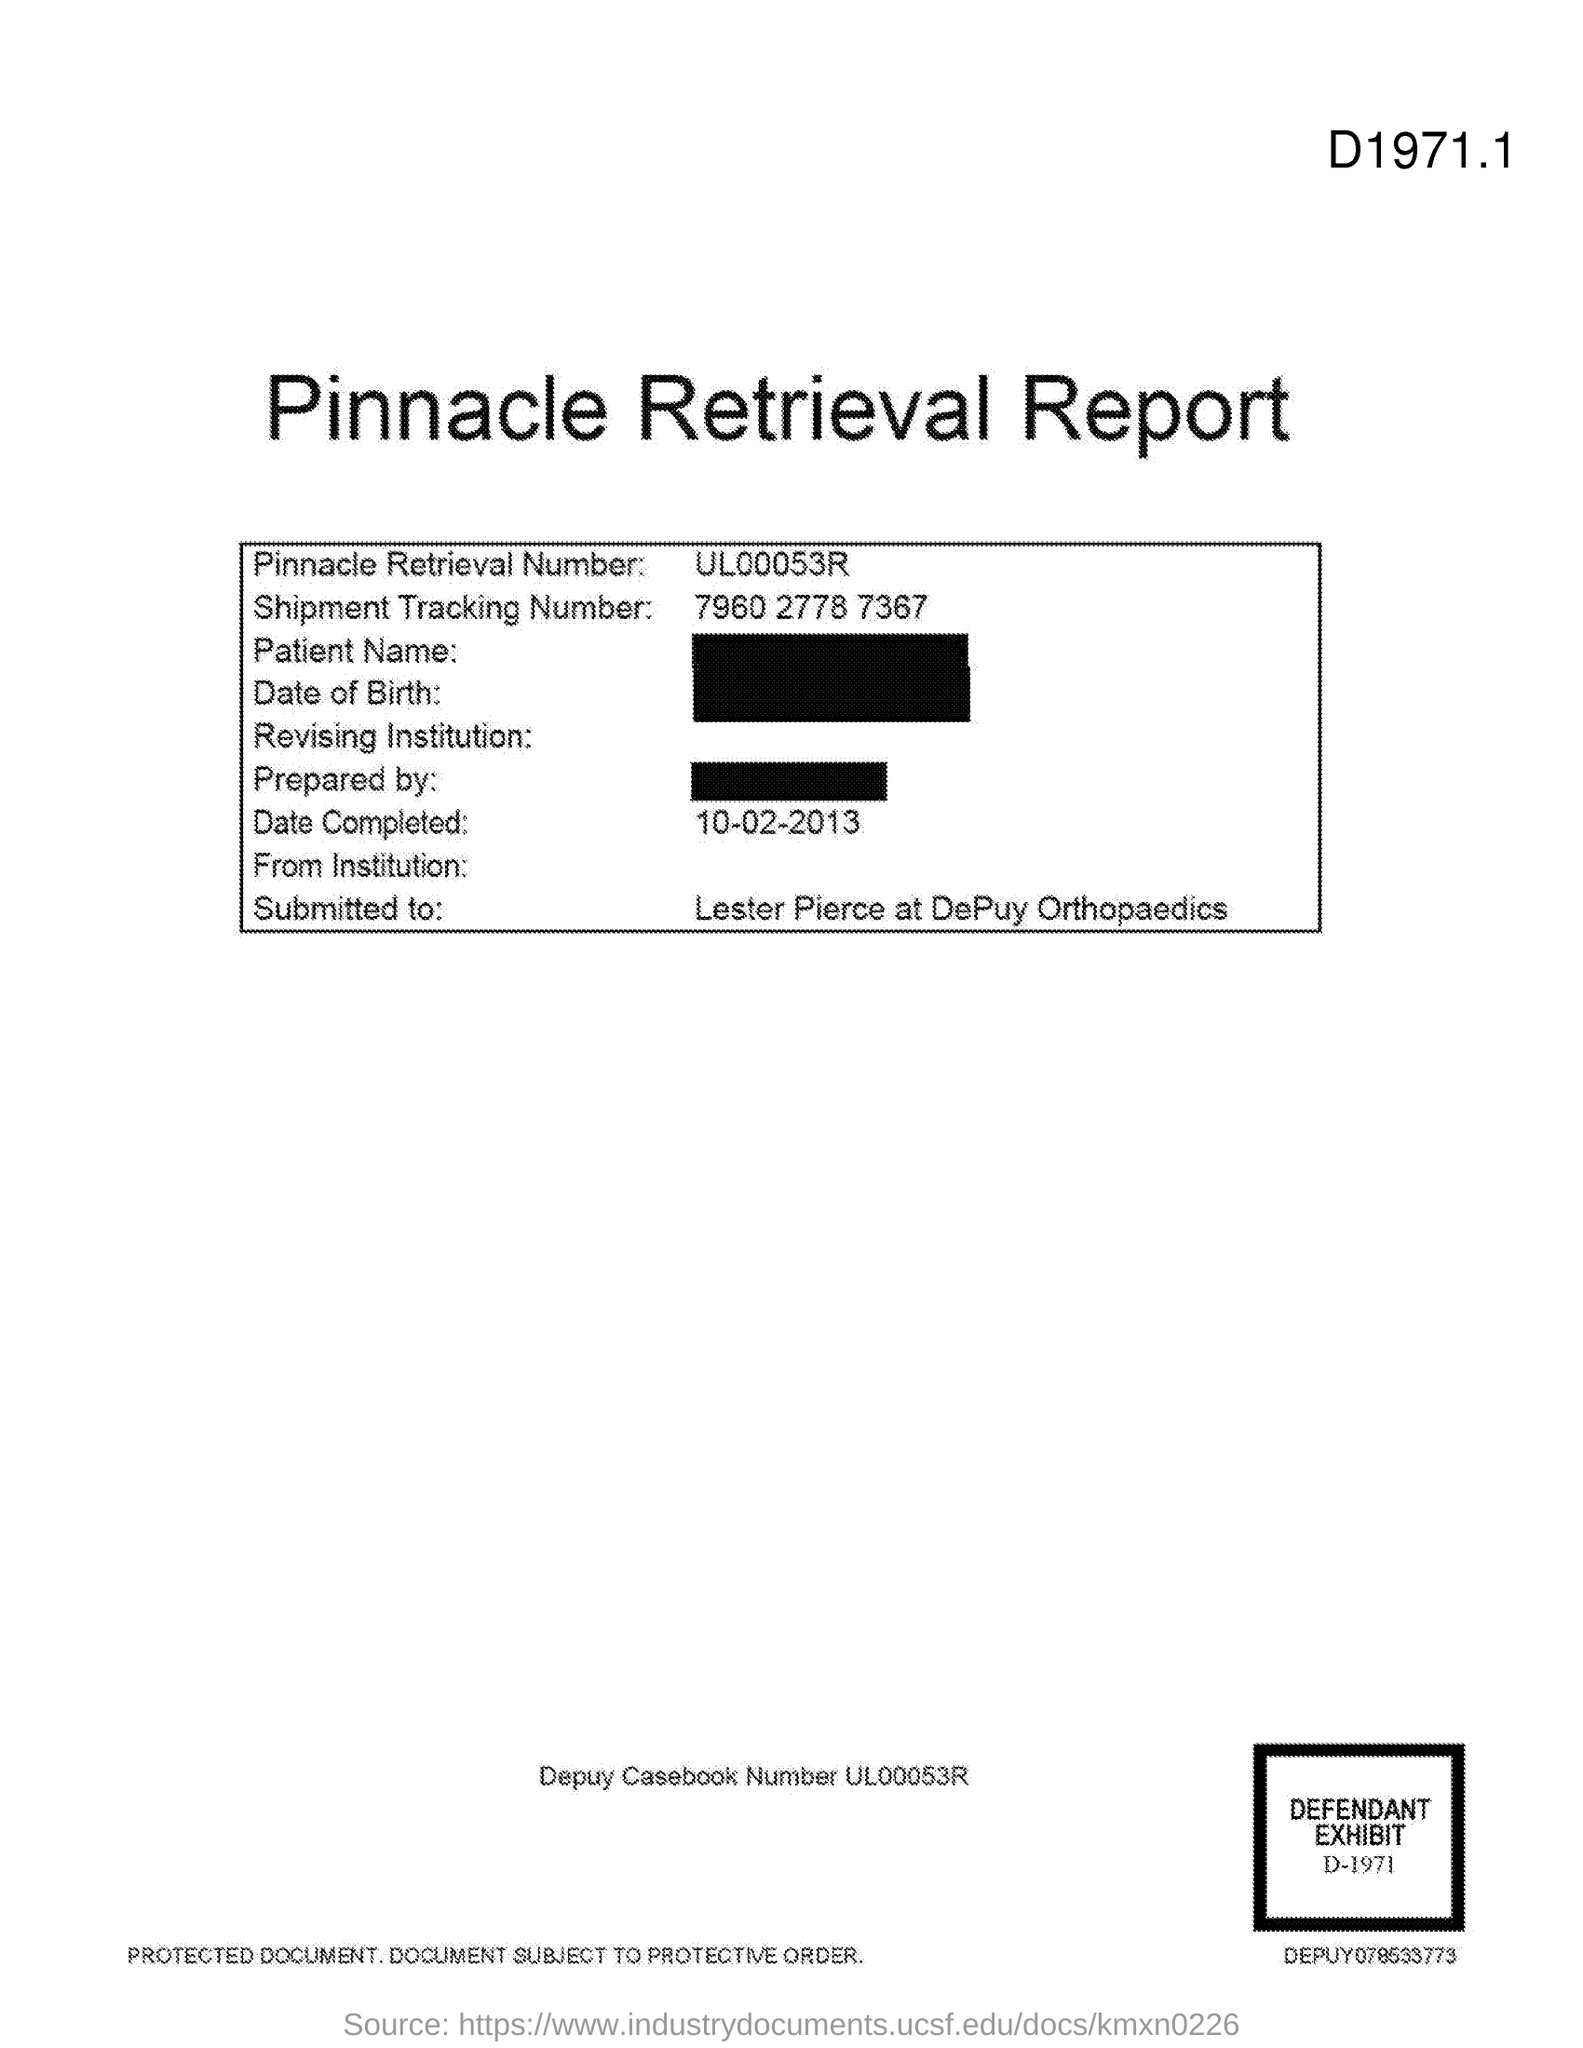Draw attention to some important aspects in this diagram. The shipment tracking number is 7960 2778 7367. The document is named the Pinnacle Retrieval Report. The Pinnacle Retrieval Number is UL00053R. 